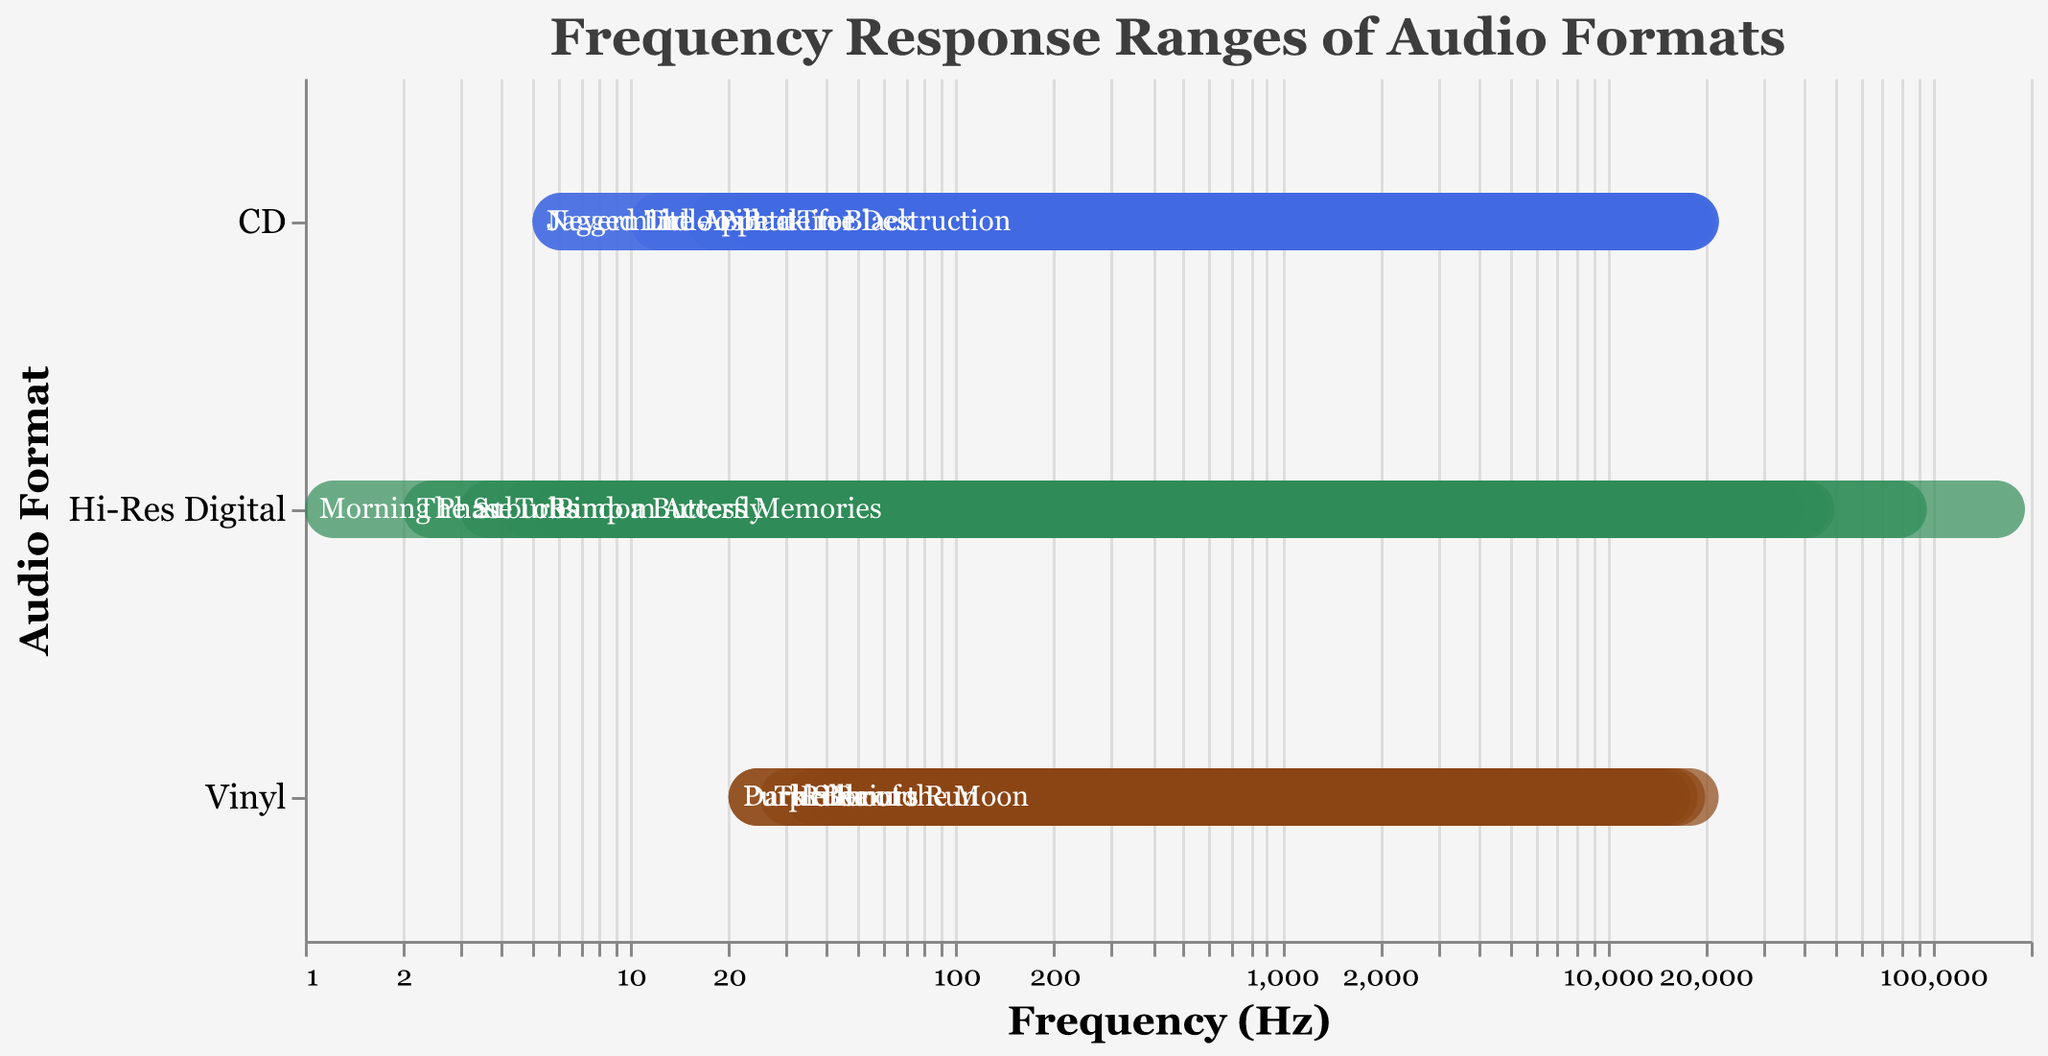What is the title of the plot? The title is usually found at the top of the plot and indicates what the plot is about.
Answer: Frequency Response Ranges of Audio Formats Which audio format has the highest maximum frequency response? By checking which format has the highest end of the frequency range, we can determine that "Hi-Res Digital" reaches up to 192000 Hz.
Answer: Hi-Res Digital How many albums are displayed in the Vinyl format? Go through the Vinyl category and count the number of distinct albums listed.
Answer: 5 What is the color representing CDs in the plot? The color representing each format is part of the legend. By checking the color coded for CD, we find it is a shade of blue.
Answer: Blue Which album has the widest frequency range? Identify the album with the largest difference between the low and high frequency values. "Morning Phase" in Hi-Res Digital has a range from 1 Hz to 192000 Hz.
Answer: Morning Phase How do the frequency ranges of Vinyl and CD compare on average? Compute the average high and low frequencies for both formats and compare:
Vinyl averages:
Low: (20+30+25+35+20)/5 = 26 Hz
High: (20000+18000+22000+17000+19000)/5 = 19200 Hz
CD averages:
Low: (20+5+10+15+5)/5 = 11 Hz
High: (22000+22050+22000+21000+21500)/5 = 21710 Hz
Compare averages:
Vinyl: 26-19200 Hz
CD: 11-21710 Hz
Answer: Vinyl has a slightly narrower average range compared to CD Which format has the lowest minimum frequency response? Determine which format has the lowest starting value of the frequency range. "Hi-Res Digital" reaches down to 1 Hz.
Answer: Hi-Res Digital Which audio format has the most uniform frequency response ranges? By examining the consistency of the ranges, CDs show closer frequency endpoints among themselves compared to the wider variances in the other formats.
Answer: CD Which album under Hi-Res Digital has the second highest maximum frequency response? Identify the albums and their ranges under Hi-Res Digital. "The Suburbs" reaches 96000 Hz, which is the second highest after "Morning Phase".
Answer: The Suburbs What frequency range does "Thriller" (Vinyl) cover? Locate "Thriller" under Vinyl, and note its frequency range. "Thriller" has a range from 25 Hz to 22000 Hz.
Answer: 25-22000 Hz 